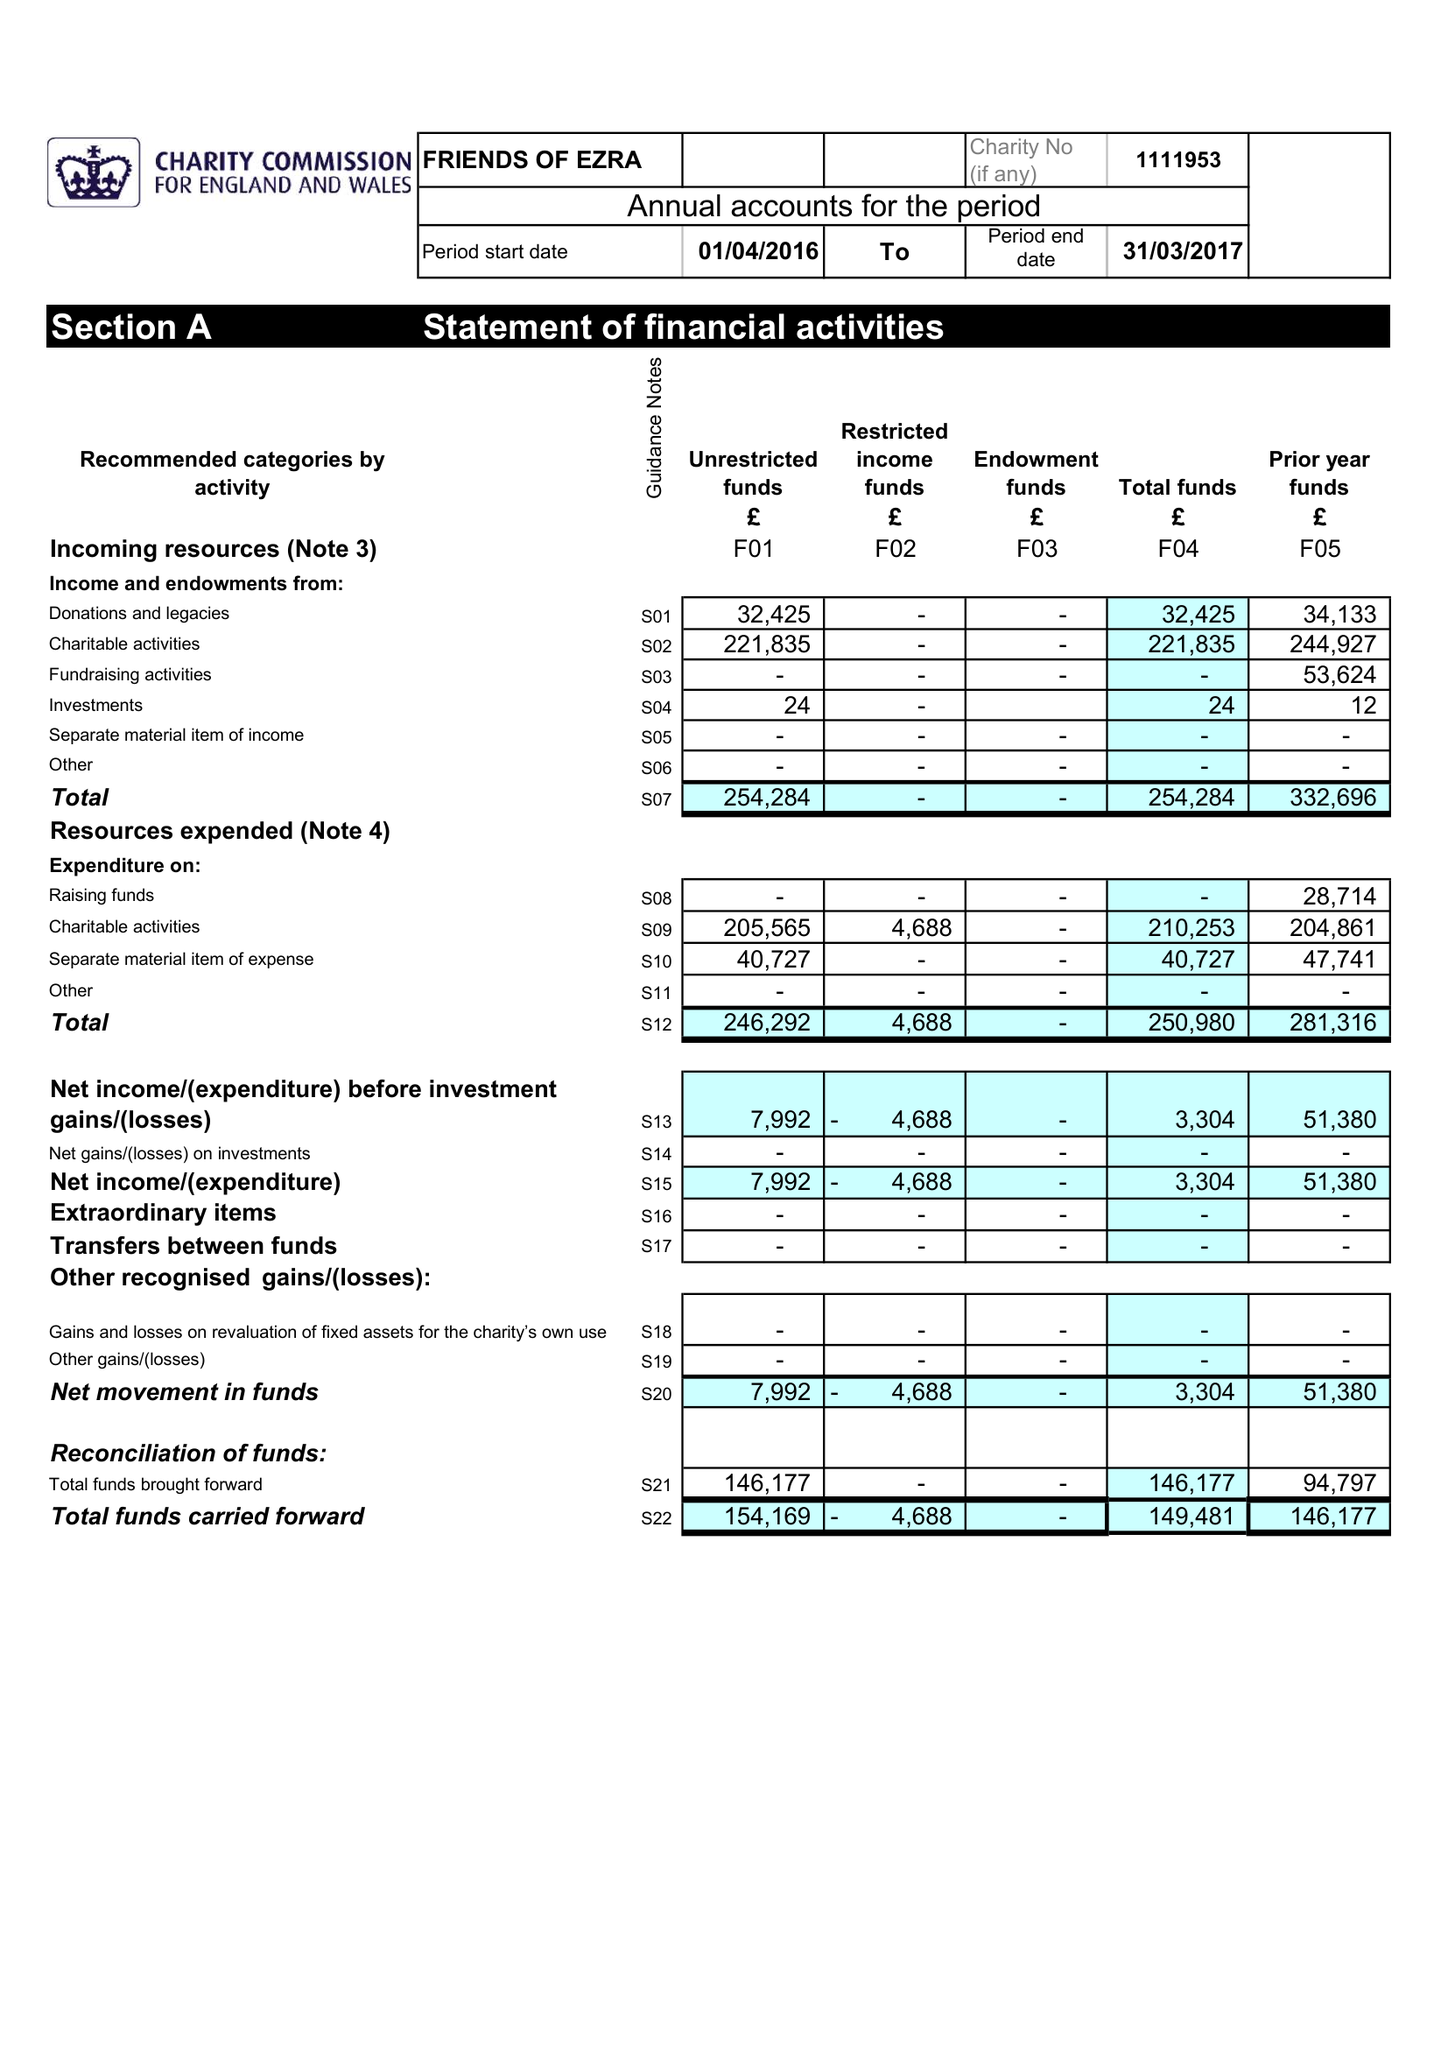What is the value for the address__street_line?
Answer the question using a single word or phrase. 35 GOLDERS GARDENS 